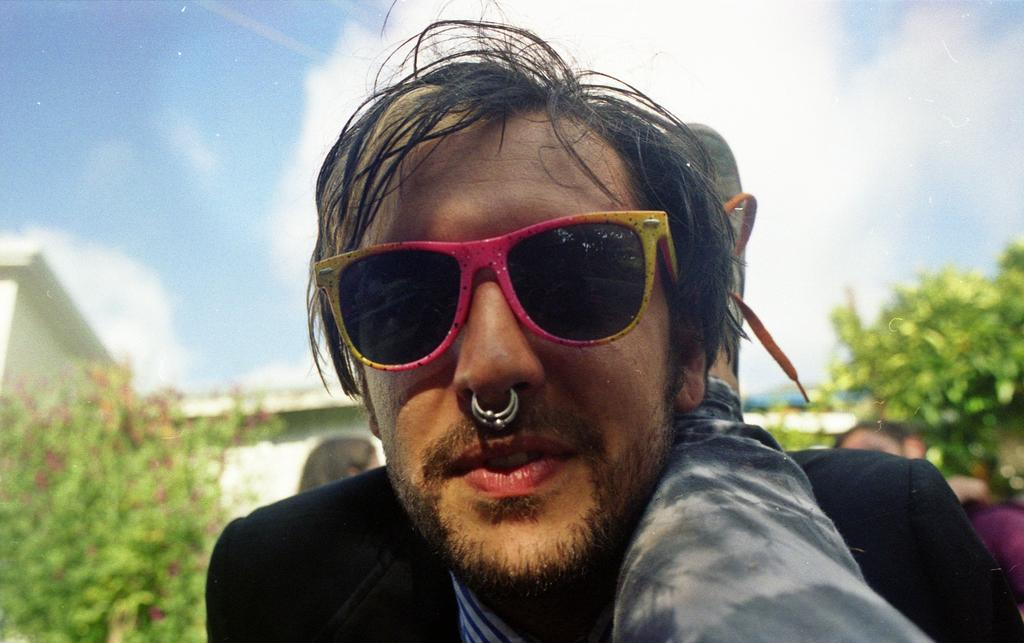What is the person in the image wearing? The person in the image is wearing glasses. What can be seen in the background of the image? There are trees and a building in the background of the image. How many people are visible in the image? There are people visible in the image. What part of the natural environment is visible in the image? The sky is visible in the image. What type of disgust can be seen on the person's face in the image? There is no indication of disgust on the person's face in the image. What type of alarm is going off in the image? There is no alarm present in the image. 